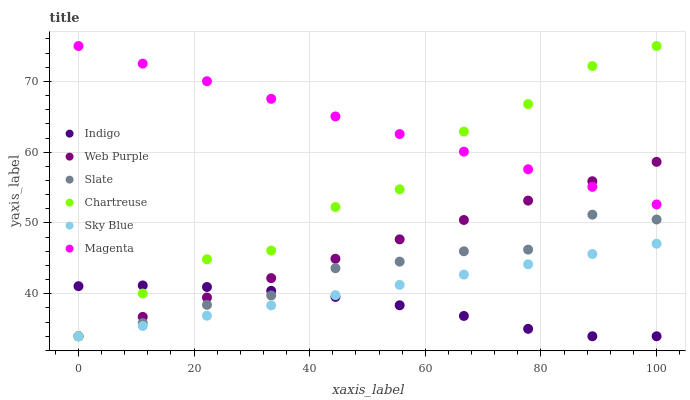Does Indigo have the minimum area under the curve?
Answer yes or no. Yes. Does Magenta have the maximum area under the curve?
Answer yes or no. Yes. Does Slate have the minimum area under the curve?
Answer yes or no. No. Does Slate have the maximum area under the curve?
Answer yes or no. No. Is Sky Blue the smoothest?
Answer yes or no. Yes. Is Chartreuse the roughest?
Answer yes or no. Yes. Is Slate the smoothest?
Answer yes or no. No. Is Slate the roughest?
Answer yes or no. No. Does Indigo have the lowest value?
Answer yes or no. Yes. Does Magenta have the lowest value?
Answer yes or no. No. Does Magenta have the highest value?
Answer yes or no. Yes. Does Slate have the highest value?
Answer yes or no. No. Is Slate less than Magenta?
Answer yes or no. Yes. Is Magenta greater than Indigo?
Answer yes or no. Yes. Does Chartreuse intersect Sky Blue?
Answer yes or no. Yes. Is Chartreuse less than Sky Blue?
Answer yes or no. No. Is Chartreuse greater than Sky Blue?
Answer yes or no. No. Does Slate intersect Magenta?
Answer yes or no. No. 